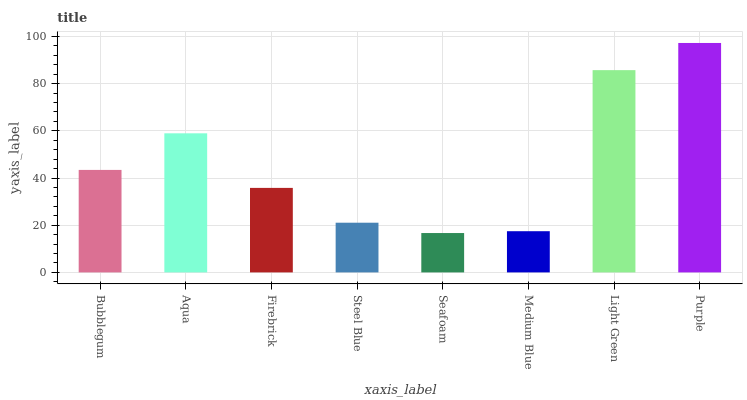Is Seafoam the minimum?
Answer yes or no. Yes. Is Purple the maximum?
Answer yes or no. Yes. Is Aqua the minimum?
Answer yes or no. No. Is Aqua the maximum?
Answer yes or no. No. Is Aqua greater than Bubblegum?
Answer yes or no. Yes. Is Bubblegum less than Aqua?
Answer yes or no. Yes. Is Bubblegum greater than Aqua?
Answer yes or no. No. Is Aqua less than Bubblegum?
Answer yes or no. No. Is Bubblegum the high median?
Answer yes or no. Yes. Is Firebrick the low median?
Answer yes or no. Yes. Is Seafoam the high median?
Answer yes or no. No. Is Aqua the low median?
Answer yes or no. No. 